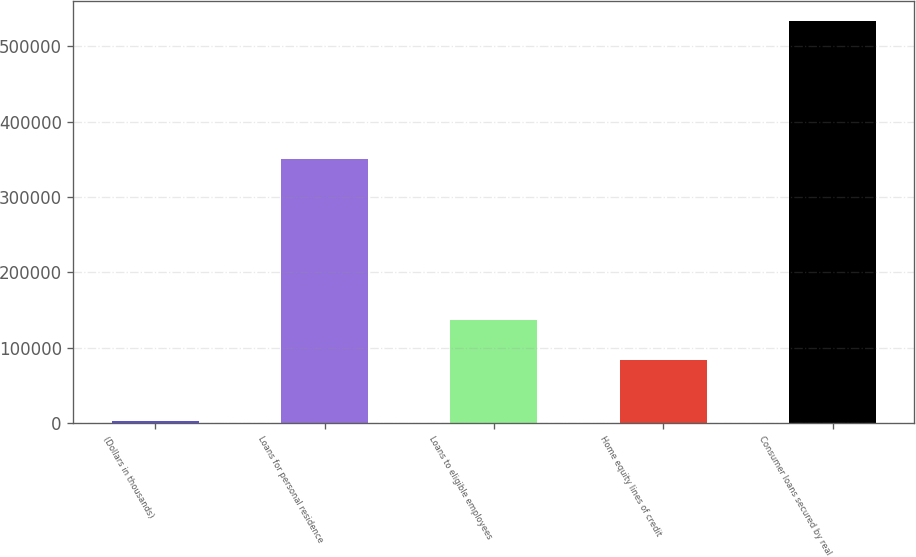<chart> <loc_0><loc_0><loc_500><loc_500><bar_chart><fcel>(Dollars in thousands)<fcel>Loans for personal residence<fcel>Loans to eligible employees<fcel>Home equity lines of credit<fcel>Consumer loans secured by real<nl><fcel>2011<fcel>350359<fcel>137137<fcel>83938<fcel>534001<nl></chart> 